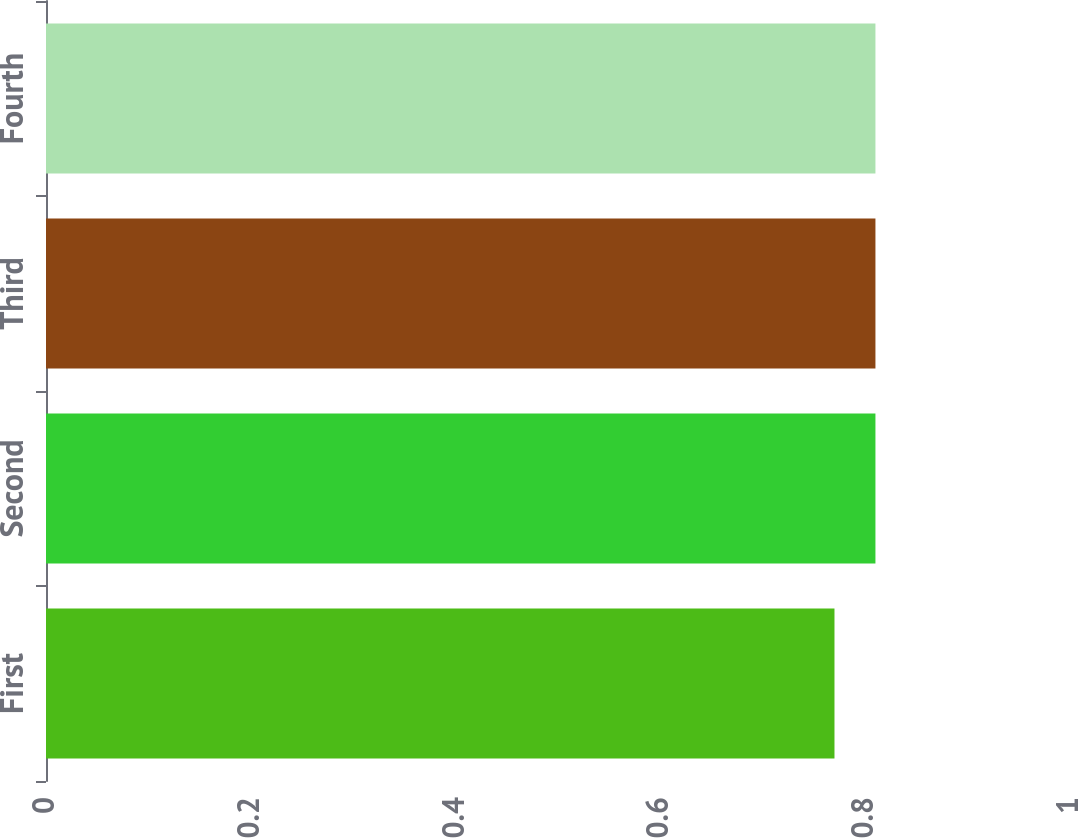Convert chart to OTSL. <chart><loc_0><loc_0><loc_500><loc_500><bar_chart><fcel>First<fcel>Second<fcel>Third<fcel>Fourth<nl><fcel>0.77<fcel>0.81<fcel>0.81<fcel>0.81<nl></chart> 